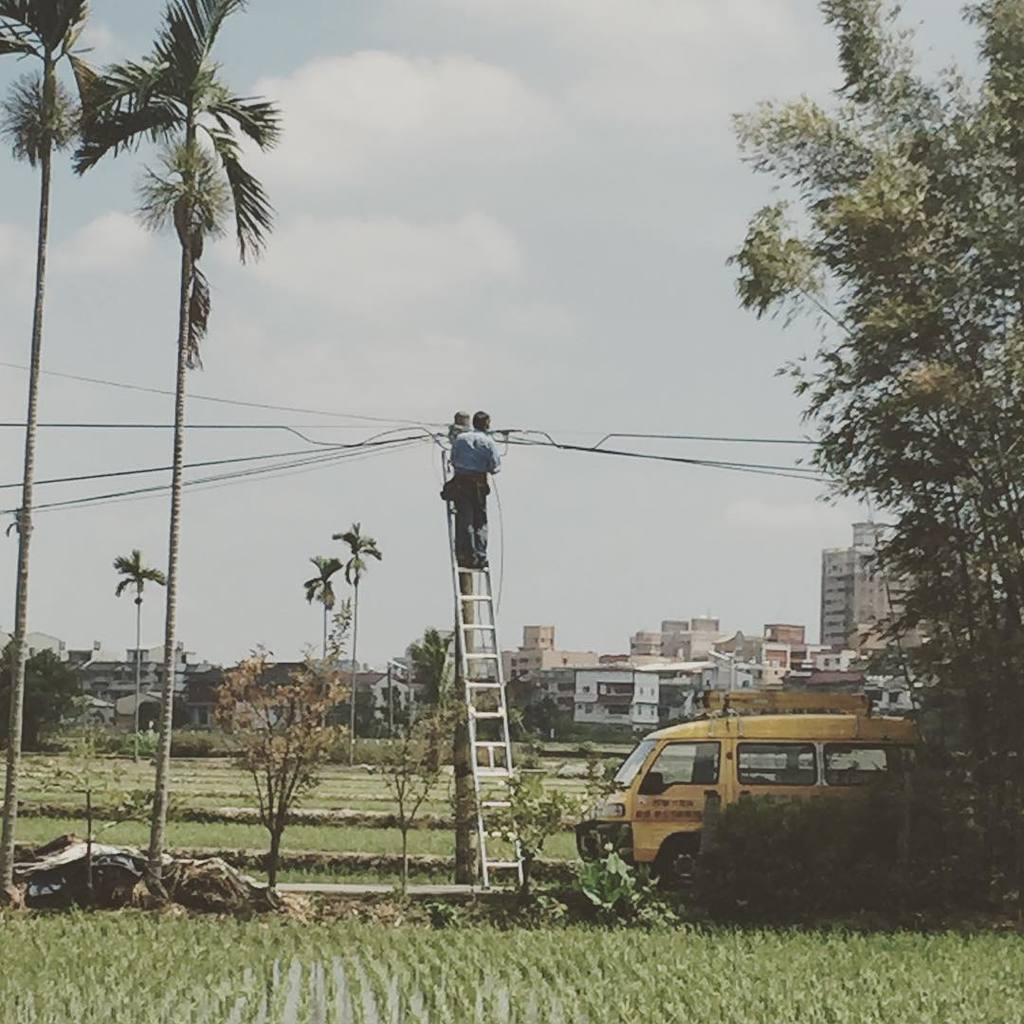What type of vegetation is predominant in the image? There are a lot of trees in the image. What is the man on the ladder doing? The man on the ladder is not doing anything specific in the image. What type of vehicle is present in the image? There is a van in the image. What type of ground surface is visible in the front of the image? There is grass in the front of the image. What type of structures can be seen in the background of the image? There are buildings in the background of the image. What is visible at the top of the image? The sky is visible at the top of the image. How many cabbages are being harvested by the ants in the image? There are no cabbages or ants present in the image. What type of tomatoes are growing on the trees in the image? There are no tomatoes or trees with tomatoes in the image. 